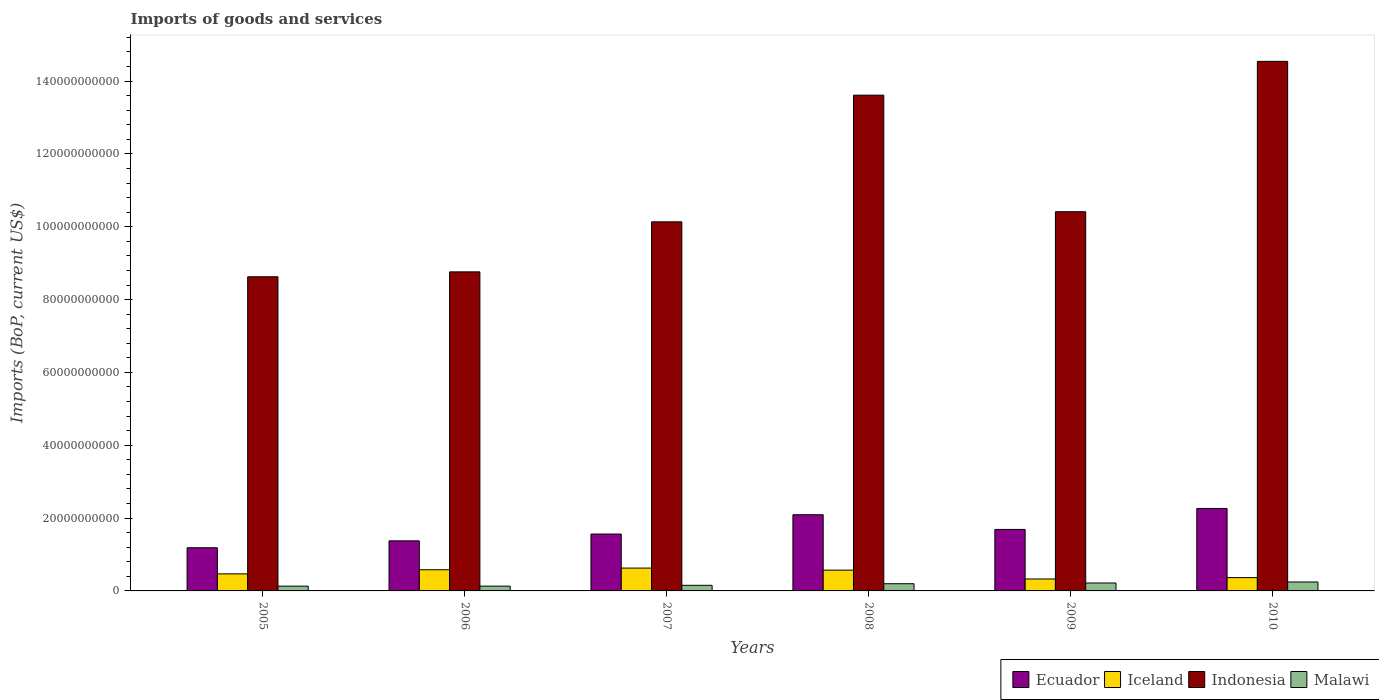Are the number of bars per tick equal to the number of legend labels?
Make the answer very short. Yes. How many bars are there on the 2nd tick from the right?
Make the answer very short. 4. What is the amount spent on imports in Iceland in 2005?
Keep it short and to the point. 4.68e+09. Across all years, what is the maximum amount spent on imports in Iceland?
Keep it short and to the point. 6.27e+09. Across all years, what is the minimum amount spent on imports in Iceland?
Provide a short and direct response. 3.28e+09. In which year was the amount spent on imports in Ecuador minimum?
Keep it short and to the point. 2005. What is the total amount spent on imports in Iceland in the graph?
Keep it short and to the point. 2.94e+1. What is the difference between the amount spent on imports in Iceland in 2008 and that in 2009?
Ensure brevity in your answer.  2.43e+09. What is the difference between the amount spent on imports in Ecuador in 2005 and the amount spent on imports in Iceland in 2006?
Give a very brief answer. 6.04e+09. What is the average amount spent on imports in Iceland per year?
Your answer should be very brief. 4.90e+09. In the year 2006, what is the difference between the amount spent on imports in Iceland and amount spent on imports in Ecuador?
Ensure brevity in your answer.  -7.93e+09. What is the ratio of the amount spent on imports in Iceland in 2005 to that in 2009?
Give a very brief answer. 1.43. Is the amount spent on imports in Iceland in 2005 less than that in 2010?
Your answer should be very brief. No. What is the difference between the highest and the second highest amount spent on imports in Malawi?
Offer a terse response. 2.83e+08. What is the difference between the highest and the lowest amount spent on imports in Malawi?
Your answer should be very brief. 1.15e+09. In how many years, is the amount spent on imports in Malawi greater than the average amount spent on imports in Malawi taken over all years?
Offer a very short reply. 3. Is the sum of the amount spent on imports in Iceland in 2009 and 2010 greater than the maximum amount spent on imports in Ecuador across all years?
Offer a terse response. No. Is it the case that in every year, the sum of the amount spent on imports in Ecuador and amount spent on imports in Iceland is greater than the sum of amount spent on imports in Indonesia and amount spent on imports in Malawi?
Your answer should be very brief. No. What does the 1st bar from the left in 2006 represents?
Make the answer very short. Ecuador. Where does the legend appear in the graph?
Offer a terse response. Bottom right. What is the title of the graph?
Give a very brief answer. Imports of goods and services. Does "Middle East & North Africa (all income levels)" appear as one of the legend labels in the graph?
Keep it short and to the point. No. What is the label or title of the X-axis?
Offer a terse response. Years. What is the label or title of the Y-axis?
Ensure brevity in your answer.  Imports (BoP, current US$). What is the Imports (BoP, current US$) in Ecuador in 2005?
Your answer should be very brief. 1.19e+1. What is the Imports (BoP, current US$) in Iceland in 2005?
Offer a very short reply. 4.68e+09. What is the Imports (BoP, current US$) of Indonesia in 2005?
Provide a short and direct response. 8.63e+1. What is the Imports (BoP, current US$) in Malawi in 2005?
Offer a very short reply. 1.31e+09. What is the Imports (BoP, current US$) in Ecuador in 2006?
Give a very brief answer. 1.37e+1. What is the Imports (BoP, current US$) in Iceland in 2006?
Give a very brief answer. 5.82e+09. What is the Imports (BoP, current US$) of Indonesia in 2006?
Your answer should be compact. 8.76e+1. What is the Imports (BoP, current US$) of Malawi in 2006?
Provide a succinct answer. 1.32e+09. What is the Imports (BoP, current US$) in Ecuador in 2007?
Your answer should be compact. 1.56e+1. What is the Imports (BoP, current US$) in Iceland in 2007?
Provide a short and direct response. 6.27e+09. What is the Imports (BoP, current US$) of Indonesia in 2007?
Ensure brevity in your answer.  1.01e+11. What is the Imports (BoP, current US$) in Malawi in 2007?
Your response must be concise. 1.54e+09. What is the Imports (BoP, current US$) in Ecuador in 2008?
Give a very brief answer. 2.09e+1. What is the Imports (BoP, current US$) of Iceland in 2008?
Keep it short and to the point. 5.71e+09. What is the Imports (BoP, current US$) in Indonesia in 2008?
Your answer should be compact. 1.36e+11. What is the Imports (BoP, current US$) in Malawi in 2008?
Offer a very short reply. 1.98e+09. What is the Imports (BoP, current US$) in Ecuador in 2009?
Provide a succinct answer. 1.69e+1. What is the Imports (BoP, current US$) in Iceland in 2009?
Offer a very short reply. 3.28e+09. What is the Imports (BoP, current US$) of Indonesia in 2009?
Your response must be concise. 1.04e+11. What is the Imports (BoP, current US$) of Malawi in 2009?
Offer a terse response. 2.18e+09. What is the Imports (BoP, current US$) in Ecuador in 2010?
Provide a short and direct response. 2.26e+1. What is the Imports (BoP, current US$) of Iceland in 2010?
Offer a very short reply. 3.65e+09. What is the Imports (BoP, current US$) of Indonesia in 2010?
Provide a succinct answer. 1.45e+11. What is the Imports (BoP, current US$) of Malawi in 2010?
Keep it short and to the point. 2.46e+09. Across all years, what is the maximum Imports (BoP, current US$) of Ecuador?
Your response must be concise. 2.26e+1. Across all years, what is the maximum Imports (BoP, current US$) in Iceland?
Ensure brevity in your answer.  6.27e+09. Across all years, what is the maximum Imports (BoP, current US$) of Indonesia?
Your answer should be very brief. 1.45e+11. Across all years, what is the maximum Imports (BoP, current US$) in Malawi?
Offer a terse response. 2.46e+09. Across all years, what is the minimum Imports (BoP, current US$) of Ecuador?
Give a very brief answer. 1.19e+1. Across all years, what is the minimum Imports (BoP, current US$) of Iceland?
Provide a succinct answer. 3.28e+09. Across all years, what is the minimum Imports (BoP, current US$) in Indonesia?
Offer a terse response. 8.63e+1. Across all years, what is the minimum Imports (BoP, current US$) in Malawi?
Make the answer very short. 1.31e+09. What is the total Imports (BoP, current US$) in Ecuador in the graph?
Your answer should be compact. 1.02e+11. What is the total Imports (BoP, current US$) in Iceland in the graph?
Give a very brief answer. 2.94e+1. What is the total Imports (BoP, current US$) of Indonesia in the graph?
Keep it short and to the point. 6.61e+11. What is the total Imports (BoP, current US$) in Malawi in the graph?
Offer a terse response. 1.08e+1. What is the difference between the Imports (BoP, current US$) of Ecuador in 2005 and that in 2006?
Make the answer very short. -1.90e+09. What is the difference between the Imports (BoP, current US$) of Iceland in 2005 and that in 2006?
Offer a terse response. -1.13e+09. What is the difference between the Imports (BoP, current US$) in Indonesia in 2005 and that in 2006?
Your answer should be compact. -1.35e+09. What is the difference between the Imports (BoP, current US$) in Malawi in 2005 and that in 2006?
Your answer should be compact. -1.06e+07. What is the difference between the Imports (BoP, current US$) in Ecuador in 2005 and that in 2007?
Your response must be concise. -3.77e+09. What is the difference between the Imports (BoP, current US$) in Iceland in 2005 and that in 2007?
Provide a succinct answer. -1.59e+09. What is the difference between the Imports (BoP, current US$) in Indonesia in 2005 and that in 2007?
Your answer should be very brief. -1.51e+1. What is the difference between the Imports (BoP, current US$) in Malawi in 2005 and that in 2007?
Keep it short and to the point. -2.29e+08. What is the difference between the Imports (BoP, current US$) in Ecuador in 2005 and that in 2008?
Give a very brief answer. -9.07e+09. What is the difference between the Imports (BoP, current US$) of Iceland in 2005 and that in 2008?
Your response must be concise. -1.03e+09. What is the difference between the Imports (BoP, current US$) in Indonesia in 2005 and that in 2008?
Offer a terse response. -4.99e+1. What is the difference between the Imports (BoP, current US$) of Malawi in 2005 and that in 2008?
Give a very brief answer. -6.68e+08. What is the difference between the Imports (BoP, current US$) in Ecuador in 2005 and that in 2009?
Make the answer very short. -5.04e+09. What is the difference between the Imports (BoP, current US$) of Iceland in 2005 and that in 2009?
Offer a terse response. 1.40e+09. What is the difference between the Imports (BoP, current US$) of Indonesia in 2005 and that in 2009?
Provide a short and direct response. -1.79e+1. What is the difference between the Imports (BoP, current US$) in Malawi in 2005 and that in 2009?
Your answer should be very brief. -8.66e+08. What is the difference between the Imports (BoP, current US$) of Ecuador in 2005 and that in 2010?
Your answer should be compact. -1.08e+1. What is the difference between the Imports (BoP, current US$) of Iceland in 2005 and that in 2010?
Give a very brief answer. 1.03e+09. What is the difference between the Imports (BoP, current US$) of Indonesia in 2005 and that in 2010?
Your answer should be compact. -5.92e+1. What is the difference between the Imports (BoP, current US$) of Malawi in 2005 and that in 2010?
Make the answer very short. -1.15e+09. What is the difference between the Imports (BoP, current US$) of Ecuador in 2006 and that in 2007?
Ensure brevity in your answer.  -1.87e+09. What is the difference between the Imports (BoP, current US$) in Iceland in 2006 and that in 2007?
Your answer should be very brief. -4.53e+08. What is the difference between the Imports (BoP, current US$) in Indonesia in 2006 and that in 2007?
Provide a succinct answer. -1.37e+1. What is the difference between the Imports (BoP, current US$) in Malawi in 2006 and that in 2007?
Make the answer very short. -2.18e+08. What is the difference between the Imports (BoP, current US$) in Ecuador in 2006 and that in 2008?
Your response must be concise. -7.18e+09. What is the difference between the Imports (BoP, current US$) of Iceland in 2006 and that in 2008?
Ensure brevity in your answer.  1.07e+08. What is the difference between the Imports (BoP, current US$) in Indonesia in 2006 and that in 2008?
Give a very brief answer. -4.85e+1. What is the difference between the Imports (BoP, current US$) of Malawi in 2006 and that in 2008?
Offer a terse response. -6.58e+08. What is the difference between the Imports (BoP, current US$) of Ecuador in 2006 and that in 2009?
Provide a succinct answer. -3.14e+09. What is the difference between the Imports (BoP, current US$) of Iceland in 2006 and that in 2009?
Give a very brief answer. 2.54e+09. What is the difference between the Imports (BoP, current US$) of Indonesia in 2006 and that in 2009?
Give a very brief answer. -1.65e+1. What is the difference between the Imports (BoP, current US$) of Malawi in 2006 and that in 2009?
Give a very brief answer. -8.56e+08. What is the difference between the Imports (BoP, current US$) of Ecuador in 2006 and that in 2010?
Provide a short and direct response. -8.89e+09. What is the difference between the Imports (BoP, current US$) in Iceland in 2006 and that in 2010?
Your answer should be very brief. 2.16e+09. What is the difference between the Imports (BoP, current US$) in Indonesia in 2006 and that in 2010?
Make the answer very short. -5.78e+1. What is the difference between the Imports (BoP, current US$) in Malawi in 2006 and that in 2010?
Provide a succinct answer. -1.14e+09. What is the difference between the Imports (BoP, current US$) in Ecuador in 2007 and that in 2008?
Your response must be concise. -5.31e+09. What is the difference between the Imports (BoP, current US$) of Iceland in 2007 and that in 2008?
Offer a terse response. 5.60e+08. What is the difference between the Imports (BoP, current US$) of Indonesia in 2007 and that in 2008?
Your response must be concise. -3.48e+1. What is the difference between the Imports (BoP, current US$) of Malawi in 2007 and that in 2008?
Your answer should be very brief. -4.40e+08. What is the difference between the Imports (BoP, current US$) in Ecuador in 2007 and that in 2009?
Make the answer very short. -1.27e+09. What is the difference between the Imports (BoP, current US$) of Iceland in 2007 and that in 2009?
Provide a succinct answer. 2.99e+09. What is the difference between the Imports (BoP, current US$) of Indonesia in 2007 and that in 2009?
Offer a very short reply. -2.78e+09. What is the difference between the Imports (BoP, current US$) of Malawi in 2007 and that in 2009?
Ensure brevity in your answer.  -6.38e+08. What is the difference between the Imports (BoP, current US$) in Ecuador in 2007 and that in 2010?
Offer a terse response. -7.02e+09. What is the difference between the Imports (BoP, current US$) in Iceland in 2007 and that in 2010?
Give a very brief answer. 2.61e+09. What is the difference between the Imports (BoP, current US$) in Indonesia in 2007 and that in 2010?
Provide a short and direct response. -4.41e+1. What is the difference between the Imports (BoP, current US$) in Malawi in 2007 and that in 2010?
Your answer should be compact. -9.20e+08. What is the difference between the Imports (BoP, current US$) of Ecuador in 2008 and that in 2009?
Offer a terse response. 4.04e+09. What is the difference between the Imports (BoP, current US$) of Iceland in 2008 and that in 2009?
Keep it short and to the point. 2.43e+09. What is the difference between the Imports (BoP, current US$) of Indonesia in 2008 and that in 2009?
Provide a succinct answer. 3.20e+1. What is the difference between the Imports (BoP, current US$) of Malawi in 2008 and that in 2009?
Provide a short and direct response. -1.98e+08. What is the difference between the Imports (BoP, current US$) of Ecuador in 2008 and that in 2010?
Your response must be concise. -1.71e+09. What is the difference between the Imports (BoP, current US$) of Iceland in 2008 and that in 2010?
Provide a short and direct response. 2.05e+09. What is the difference between the Imports (BoP, current US$) of Indonesia in 2008 and that in 2010?
Offer a terse response. -9.29e+09. What is the difference between the Imports (BoP, current US$) in Malawi in 2008 and that in 2010?
Make the answer very short. -4.80e+08. What is the difference between the Imports (BoP, current US$) in Ecuador in 2009 and that in 2010?
Provide a succinct answer. -5.75e+09. What is the difference between the Imports (BoP, current US$) of Iceland in 2009 and that in 2010?
Ensure brevity in your answer.  -3.75e+08. What is the difference between the Imports (BoP, current US$) of Indonesia in 2009 and that in 2010?
Provide a short and direct response. -4.13e+1. What is the difference between the Imports (BoP, current US$) of Malawi in 2009 and that in 2010?
Give a very brief answer. -2.83e+08. What is the difference between the Imports (BoP, current US$) in Ecuador in 2005 and the Imports (BoP, current US$) in Iceland in 2006?
Your response must be concise. 6.04e+09. What is the difference between the Imports (BoP, current US$) in Ecuador in 2005 and the Imports (BoP, current US$) in Indonesia in 2006?
Offer a very short reply. -7.58e+1. What is the difference between the Imports (BoP, current US$) in Ecuador in 2005 and the Imports (BoP, current US$) in Malawi in 2006?
Your response must be concise. 1.05e+1. What is the difference between the Imports (BoP, current US$) in Iceland in 2005 and the Imports (BoP, current US$) in Indonesia in 2006?
Offer a terse response. -8.29e+1. What is the difference between the Imports (BoP, current US$) of Iceland in 2005 and the Imports (BoP, current US$) of Malawi in 2006?
Make the answer very short. 3.36e+09. What is the difference between the Imports (BoP, current US$) in Indonesia in 2005 and the Imports (BoP, current US$) in Malawi in 2006?
Provide a short and direct response. 8.49e+1. What is the difference between the Imports (BoP, current US$) in Ecuador in 2005 and the Imports (BoP, current US$) in Iceland in 2007?
Make the answer very short. 5.58e+09. What is the difference between the Imports (BoP, current US$) of Ecuador in 2005 and the Imports (BoP, current US$) of Indonesia in 2007?
Your answer should be compact. -8.95e+1. What is the difference between the Imports (BoP, current US$) of Ecuador in 2005 and the Imports (BoP, current US$) of Malawi in 2007?
Offer a very short reply. 1.03e+1. What is the difference between the Imports (BoP, current US$) in Iceland in 2005 and the Imports (BoP, current US$) in Indonesia in 2007?
Offer a terse response. -9.67e+1. What is the difference between the Imports (BoP, current US$) in Iceland in 2005 and the Imports (BoP, current US$) in Malawi in 2007?
Make the answer very short. 3.14e+09. What is the difference between the Imports (BoP, current US$) of Indonesia in 2005 and the Imports (BoP, current US$) of Malawi in 2007?
Offer a terse response. 8.47e+1. What is the difference between the Imports (BoP, current US$) in Ecuador in 2005 and the Imports (BoP, current US$) in Iceland in 2008?
Offer a very short reply. 6.14e+09. What is the difference between the Imports (BoP, current US$) in Ecuador in 2005 and the Imports (BoP, current US$) in Indonesia in 2008?
Make the answer very short. -1.24e+11. What is the difference between the Imports (BoP, current US$) in Ecuador in 2005 and the Imports (BoP, current US$) in Malawi in 2008?
Ensure brevity in your answer.  9.87e+09. What is the difference between the Imports (BoP, current US$) of Iceland in 2005 and the Imports (BoP, current US$) of Indonesia in 2008?
Your answer should be compact. -1.31e+11. What is the difference between the Imports (BoP, current US$) in Iceland in 2005 and the Imports (BoP, current US$) in Malawi in 2008?
Offer a very short reply. 2.70e+09. What is the difference between the Imports (BoP, current US$) of Indonesia in 2005 and the Imports (BoP, current US$) of Malawi in 2008?
Provide a short and direct response. 8.43e+1. What is the difference between the Imports (BoP, current US$) in Ecuador in 2005 and the Imports (BoP, current US$) in Iceland in 2009?
Your answer should be very brief. 8.57e+09. What is the difference between the Imports (BoP, current US$) in Ecuador in 2005 and the Imports (BoP, current US$) in Indonesia in 2009?
Your answer should be compact. -9.23e+1. What is the difference between the Imports (BoP, current US$) of Ecuador in 2005 and the Imports (BoP, current US$) of Malawi in 2009?
Ensure brevity in your answer.  9.68e+09. What is the difference between the Imports (BoP, current US$) in Iceland in 2005 and the Imports (BoP, current US$) in Indonesia in 2009?
Give a very brief answer. -9.94e+1. What is the difference between the Imports (BoP, current US$) of Iceland in 2005 and the Imports (BoP, current US$) of Malawi in 2009?
Offer a very short reply. 2.51e+09. What is the difference between the Imports (BoP, current US$) in Indonesia in 2005 and the Imports (BoP, current US$) in Malawi in 2009?
Provide a succinct answer. 8.41e+1. What is the difference between the Imports (BoP, current US$) of Ecuador in 2005 and the Imports (BoP, current US$) of Iceland in 2010?
Your response must be concise. 8.20e+09. What is the difference between the Imports (BoP, current US$) of Ecuador in 2005 and the Imports (BoP, current US$) of Indonesia in 2010?
Ensure brevity in your answer.  -1.34e+11. What is the difference between the Imports (BoP, current US$) of Ecuador in 2005 and the Imports (BoP, current US$) of Malawi in 2010?
Your response must be concise. 9.39e+09. What is the difference between the Imports (BoP, current US$) of Iceland in 2005 and the Imports (BoP, current US$) of Indonesia in 2010?
Your answer should be compact. -1.41e+11. What is the difference between the Imports (BoP, current US$) in Iceland in 2005 and the Imports (BoP, current US$) in Malawi in 2010?
Offer a terse response. 2.22e+09. What is the difference between the Imports (BoP, current US$) in Indonesia in 2005 and the Imports (BoP, current US$) in Malawi in 2010?
Offer a terse response. 8.38e+1. What is the difference between the Imports (BoP, current US$) in Ecuador in 2006 and the Imports (BoP, current US$) in Iceland in 2007?
Make the answer very short. 7.48e+09. What is the difference between the Imports (BoP, current US$) of Ecuador in 2006 and the Imports (BoP, current US$) of Indonesia in 2007?
Provide a short and direct response. -8.76e+1. What is the difference between the Imports (BoP, current US$) in Ecuador in 2006 and the Imports (BoP, current US$) in Malawi in 2007?
Keep it short and to the point. 1.22e+1. What is the difference between the Imports (BoP, current US$) in Iceland in 2006 and the Imports (BoP, current US$) in Indonesia in 2007?
Your answer should be very brief. -9.55e+1. What is the difference between the Imports (BoP, current US$) of Iceland in 2006 and the Imports (BoP, current US$) of Malawi in 2007?
Offer a terse response. 4.28e+09. What is the difference between the Imports (BoP, current US$) in Indonesia in 2006 and the Imports (BoP, current US$) in Malawi in 2007?
Your answer should be compact. 8.61e+1. What is the difference between the Imports (BoP, current US$) of Ecuador in 2006 and the Imports (BoP, current US$) of Iceland in 2008?
Ensure brevity in your answer.  8.04e+09. What is the difference between the Imports (BoP, current US$) of Ecuador in 2006 and the Imports (BoP, current US$) of Indonesia in 2008?
Make the answer very short. -1.22e+11. What is the difference between the Imports (BoP, current US$) in Ecuador in 2006 and the Imports (BoP, current US$) in Malawi in 2008?
Your response must be concise. 1.18e+1. What is the difference between the Imports (BoP, current US$) in Iceland in 2006 and the Imports (BoP, current US$) in Indonesia in 2008?
Make the answer very short. -1.30e+11. What is the difference between the Imports (BoP, current US$) of Iceland in 2006 and the Imports (BoP, current US$) of Malawi in 2008?
Your answer should be compact. 3.84e+09. What is the difference between the Imports (BoP, current US$) in Indonesia in 2006 and the Imports (BoP, current US$) in Malawi in 2008?
Your response must be concise. 8.56e+1. What is the difference between the Imports (BoP, current US$) in Ecuador in 2006 and the Imports (BoP, current US$) in Iceland in 2009?
Make the answer very short. 1.05e+1. What is the difference between the Imports (BoP, current US$) in Ecuador in 2006 and the Imports (BoP, current US$) in Indonesia in 2009?
Ensure brevity in your answer.  -9.04e+1. What is the difference between the Imports (BoP, current US$) in Ecuador in 2006 and the Imports (BoP, current US$) in Malawi in 2009?
Keep it short and to the point. 1.16e+1. What is the difference between the Imports (BoP, current US$) in Iceland in 2006 and the Imports (BoP, current US$) in Indonesia in 2009?
Offer a terse response. -9.83e+1. What is the difference between the Imports (BoP, current US$) in Iceland in 2006 and the Imports (BoP, current US$) in Malawi in 2009?
Provide a succinct answer. 3.64e+09. What is the difference between the Imports (BoP, current US$) in Indonesia in 2006 and the Imports (BoP, current US$) in Malawi in 2009?
Make the answer very short. 8.54e+1. What is the difference between the Imports (BoP, current US$) of Ecuador in 2006 and the Imports (BoP, current US$) of Iceland in 2010?
Offer a very short reply. 1.01e+1. What is the difference between the Imports (BoP, current US$) in Ecuador in 2006 and the Imports (BoP, current US$) in Indonesia in 2010?
Your response must be concise. -1.32e+11. What is the difference between the Imports (BoP, current US$) in Ecuador in 2006 and the Imports (BoP, current US$) in Malawi in 2010?
Offer a terse response. 1.13e+1. What is the difference between the Imports (BoP, current US$) in Iceland in 2006 and the Imports (BoP, current US$) in Indonesia in 2010?
Provide a short and direct response. -1.40e+11. What is the difference between the Imports (BoP, current US$) in Iceland in 2006 and the Imports (BoP, current US$) in Malawi in 2010?
Your answer should be compact. 3.36e+09. What is the difference between the Imports (BoP, current US$) in Indonesia in 2006 and the Imports (BoP, current US$) in Malawi in 2010?
Give a very brief answer. 8.52e+1. What is the difference between the Imports (BoP, current US$) of Ecuador in 2007 and the Imports (BoP, current US$) of Iceland in 2008?
Provide a short and direct response. 9.91e+09. What is the difference between the Imports (BoP, current US$) of Ecuador in 2007 and the Imports (BoP, current US$) of Indonesia in 2008?
Provide a succinct answer. -1.21e+11. What is the difference between the Imports (BoP, current US$) of Ecuador in 2007 and the Imports (BoP, current US$) of Malawi in 2008?
Ensure brevity in your answer.  1.36e+1. What is the difference between the Imports (BoP, current US$) of Iceland in 2007 and the Imports (BoP, current US$) of Indonesia in 2008?
Give a very brief answer. -1.30e+11. What is the difference between the Imports (BoP, current US$) of Iceland in 2007 and the Imports (BoP, current US$) of Malawi in 2008?
Offer a very short reply. 4.29e+09. What is the difference between the Imports (BoP, current US$) of Indonesia in 2007 and the Imports (BoP, current US$) of Malawi in 2008?
Give a very brief answer. 9.94e+1. What is the difference between the Imports (BoP, current US$) in Ecuador in 2007 and the Imports (BoP, current US$) in Iceland in 2009?
Offer a very short reply. 1.23e+1. What is the difference between the Imports (BoP, current US$) of Ecuador in 2007 and the Imports (BoP, current US$) of Indonesia in 2009?
Offer a very short reply. -8.85e+1. What is the difference between the Imports (BoP, current US$) in Ecuador in 2007 and the Imports (BoP, current US$) in Malawi in 2009?
Make the answer very short. 1.34e+1. What is the difference between the Imports (BoP, current US$) of Iceland in 2007 and the Imports (BoP, current US$) of Indonesia in 2009?
Provide a short and direct response. -9.79e+1. What is the difference between the Imports (BoP, current US$) of Iceland in 2007 and the Imports (BoP, current US$) of Malawi in 2009?
Keep it short and to the point. 4.09e+09. What is the difference between the Imports (BoP, current US$) in Indonesia in 2007 and the Imports (BoP, current US$) in Malawi in 2009?
Keep it short and to the point. 9.92e+1. What is the difference between the Imports (BoP, current US$) in Ecuador in 2007 and the Imports (BoP, current US$) in Iceland in 2010?
Your answer should be very brief. 1.20e+1. What is the difference between the Imports (BoP, current US$) of Ecuador in 2007 and the Imports (BoP, current US$) of Indonesia in 2010?
Your answer should be compact. -1.30e+11. What is the difference between the Imports (BoP, current US$) in Ecuador in 2007 and the Imports (BoP, current US$) in Malawi in 2010?
Your answer should be very brief. 1.32e+1. What is the difference between the Imports (BoP, current US$) of Iceland in 2007 and the Imports (BoP, current US$) of Indonesia in 2010?
Make the answer very short. -1.39e+11. What is the difference between the Imports (BoP, current US$) in Iceland in 2007 and the Imports (BoP, current US$) in Malawi in 2010?
Make the answer very short. 3.81e+09. What is the difference between the Imports (BoP, current US$) in Indonesia in 2007 and the Imports (BoP, current US$) in Malawi in 2010?
Give a very brief answer. 9.89e+1. What is the difference between the Imports (BoP, current US$) in Ecuador in 2008 and the Imports (BoP, current US$) in Iceland in 2009?
Provide a succinct answer. 1.76e+1. What is the difference between the Imports (BoP, current US$) in Ecuador in 2008 and the Imports (BoP, current US$) in Indonesia in 2009?
Your answer should be compact. -8.32e+1. What is the difference between the Imports (BoP, current US$) of Ecuador in 2008 and the Imports (BoP, current US$) of Malawi in 2009?
Provide a short and direct response. 1.87e+1. What is the difference between the Imports (BoP, current US$) in Iceland in 2008 and the Imports (BoP, current US$) in Indonesia in 2009?
Keep it short and to the point. -9.84e+1. What is the difference between the Imports (BoP, current US$) in Iceland in 2008 and the Imports (BoP, current US$) in Malawi in 2009?
Provide a succinct answer. 3.53e+09. What is the difference between the Imports (BoP, current US$) of Indonesia in 2008 and the Imports (BoP, current US$) of Malawi in 2009?
Provide a short and direct response. 1.34e+11. What is the difference between the Imports (BoP, current US$) of Ecuador in 2008 and the Imports (BoP, current US$) of Iceland in 2010?
Provide a succinct answer. 1.73e+1. What is the difference between the Imports (BoP, current US$) in Ecuador in 2008 and the Imports (BoP, current US$) in Indonesia in 2010?
Provide a short and direct response. -1.24e+11. What is the difference between the Imports (BoP, current US$) in Ecuador in 2008 and the Imports (BoP, current US$) in Malawi in 2010?
Provide a short and direct response. 1.85e+1. What is the difference between the Imports (BoP, current US$) of Iceland in 2008 and the Imports (BoP, current US$) of Indonesia in 2010?
Make the answer very short. -1.40e+11. What is the difference between the Imports (BoP, current US$) in Iceland in 2008 and the Imports (BoP, current US$) in Malawi in 2010?
Give a very brief answer. 3.25e+09. What is the difference between the Imports (BoP, current US$) of Indonesia in 2008 and the Imports (BoP, current US$) of Malawi in 2010?
Ensure brevity in your answer.  1.34e+11. What is the difference between the Imports (BoP, current US$) in Ecuador in 2009 and the Imports (BoP, current US$) in Iceland in 2010?
Provide a short and direct response. 1.32e+1. What is the difference between the Imports (BoP, current US$) of Ecuador in 2009 and the Imports (BoP, current US$) of Indonesia in 2010?
Your answer should be very brief. -1.29e+11. What is the difference between the Imports (BoP, current US$) of Ecuador in 2009 and the Imports (BoP, current US$) of Malawi in 2010?
Provide a succinct answer. 1.44e+1. What is the difference between the Imports (BoP, current US$) in Iceland in 2009 and the Imports (BoP, current US$) in Indonesia in 2010?
Provide a succinct answer. -1.42e+11. What is the difference between the Imports (BoP, current US$) of Iceland in 2009 and the Imports (BoP, current US$) of Malawi in 2010?
Provide a short and direct response. 8.22e+08. What is the difference between the Imports (BoP, current US$) of Indonesia in 2009 and the Imports (BoP, current US$) of Malawi in 2010?
Make the answer very short. 1.02e+11. What is the average Imports (BoP, current US$) in Ecuador per year?
Provide a short and direct response. 1.69e+1. What is the average Imports (BoP, current US$) in Iceland per year?
Your response must be concise. 4.90e+09. What is the average Imports (BoP, current US$) of Indonesia per year?
Make the answer very short. 1.10e+11. What is the average Imports (BoP, current US$) of Malawi per year?
Offer a terse response. 1.80e+09. In the year 2005, what is the difference between the Imports (BoP, current US$) of Ecuador and Imports (BoP, current US$) of Iceland?
Ensure brevity in your answer.  7.17e+09. In the year 2005, what is the difference between the Imports (BoP, current US$) of Ecuador and Imports (BoP, current US$) of Indonesia?
Your response must be concise. -7.44e+1. In the year 2005, what is the difference between the Imports (BoP, current US$) in Ecuador and Imports (BoP, current US$) in Malawi?
Provide a short and direct response. 1.05e+1. In the year 2005, what is the difference between the Imports (BoP, current US$) in Iceland and Imports (BoP, current US$) in Indonesia?
Provide a succinct answer. -8.16e+1. In the year 2005, what is the difference between the Imports (BoP, current US$) in Iceland and Imports (BoP, current US$) in Malawi?
Provide a succinct answer. 3.37e+09. In the year 2005, what is the difference between the Imports (BoP, current US$) of Indonesia and Imports (BoP, current US$) of Malawi?
Make the answer very short. 8.50e+1. In the year 2006, what is the difference between the Imports (BoP, current US$) in Ecuador and Imports (BoP, current US$) in Iceland?
Provide a short and direct response. 7.93e+09. In the year 2006, what is the difference between the Imports (BoP, current US$) in Ecuador and Imports (BoP, current US$) in Indonesia?
Your response must be concise. -7.39e+1. In the year 2006, what is the difference between the Imports (BoP, current US$) of Ecuador and Imports (BoP, current US$) of Malawi?
Make the answer very short. 1.24e+1. In the year 2006, what is the difference between the Imports (BoP, current US$) of Iceland and Imports (BoP, current US$) of Indonesia?
Make the answer very short. -8.18e+1. In the year 2006, what is the difference between the Imports (BoP, current US$) in Iceland and Imports (BoP, current US$) in Malawi?
Your response must be concise. 4.50e+09. In the year 2006, what is the difference between the Imports (BoP, current US$) in Indonesia and Imports (BoP, current US$) in Malawi?
Keep it short and to the point. 8.63e+1. In the year 2007, what is the difference between the Imports (BoP, current US$) of Ecuador and Imports (BoP, current US$) of Iceland?
Ensure brevity in your answer.  9.35e+09. In the year 2007, what is the difference between the Imports (BoP, current US$) in Ecuador and Imports (BoP, current US$) in Indonesia?
Your answer should be compact. -8.57e+1. In the year 2007, what is the difference between the Imports (BoP, current US$) in Ecuador and Imports (BoP, current US$) in Malawi?
Make the answer very short. 1.41e+1. In the year 2007, what is the difference between the Imports (BoP, current US$) in Iceland and Imports (BoP, current US$) in Indonesia?
Offer a terse response. -9.51e+1. In the year 2007, what is the difference between the Imports (BoP, current US$) in Iceland and Imports (BoP, current US$) in Malawi?
Your answer should be compact. 4.73e+09. In the year 2007, what is the difference between the Imports (BoP, current US$) of Indonesia and Imports (BoP, current US$) of Malawi?
Give a very brief answer. 9.98e+1. In the year 2008, what is the difference between the Imports (BoP, current US$) of Ecuador and Imports (BoP, current US$) of Iceland?
Offer a very short reply. 1.52e+1. In the year 2008, what is the difference between the Imports (BoP, current US$) in Ecuador and Imports (BoP, current US$) in Indonesia?
Provide a short and direct response. -1.15e+11. In the year 2008, what is the difference between the Imports (BoP, current US$) in Ecuador and Imports (BoP, current US$) in Malawi?
Offer a terse response. 1.89e+1. In the year 2008, what is the difference between the Imports (BoP, current US$) of Iceland and Imports (BoP, current US$) of Indonesia?
Your answer should be compact. -1.30e+11. In the year 2008, what is the difference between the Imports (BoP, current US$) of Iceland and Imports (BoP, current US$) of Malawi?
Keep it short and to the point. 3.73e+09. In the year 2008, what is the difference between the Imports (BoP, current US$) in Indonesia and Imports (BoP, current US$) in Malawi?
Make the answer very short. 1.34e+11. In the year 2009, what is the difference between the Imports (BoP, current US$) in Ecuador and Imports (BoP, current US$) in Iceland?
Give a very brief answer. 1.36e+1. In the year 2009, what is the difference between the Imports (BoP, current US$) of Ecuador and Imports (BoP, current US$) of Indonesia?
Give a very brief answer. -8.72e+1. In the year 2009, what is the difference between the Imports (BoP, current US$) of Ecuador and Imports (BoP, current US$) of Malawi?
Keep it short and to the point. 1.47e+1. In the year 2009, what is the difference between the Imports (BoP, current US$) of Iceland and Imports (BoP, current US$) of Indonesia?
Make the answer very short. -1.01e+11. In the year 2009, what is the difference between the Imports (BoP, current US$) of Iceland and Imports (BoP, current US$) of Malawi?
Your answer should be very brief. 1.10e+09. In the year 2009, what is the difference between the Imports (BoP, current US$) in Indonesia and Imports (BoP, current US$) in Malawi?
Provide a succinct answer. 1.02e+11. In the year 2010, what is the difference between the Imports (BoP, current US$) of Ecuador and Imports (BoP, current US$) of Iceland?
Offer a terse response. 1.90e+1. In the year 2010, what is the difference between the Imports (BoP, current US$) of Ecuador and Imports (BoP, current US$) of Indonesia?
Provide a short and direct response. -1.23e+11. In the year 2010, what is the difference between the Imports (BoP, current US$) of Ecuador and Imports (BoP, current US$) of Malawi?
Your answer should be compact. 2.02e+1. In the year 2010, what is the difference between the Imports (BoP, current US$) in Iceland and Imports (BoP, current US$) in Indonesia?
Give a very brief answer. -1.42e+11. In the year 2010, what is the difference between the Imports (BoP, current US$) in Iceland and Imports (BoP, current US$) in Malawi?
Your response must be concise. 1.20e+09. In the year 2010, what is the difference between the Imports (BoP, current US$) of Indonesia and Imports (BoP, current US$) of Malawi?
Your answer should be very brief. 1.43e+11. What is the ratio of the Imports (BoP, current US$) of Ecuador in 2005 to that in 2006?
Give a very brief answer. 0.86. What is the ratio of the Imports (BoP, current US$) in Iceland in 2005 to that in 2006?
Ensure brevity in your answer.  0.8. What is the ratio of the Imports (BoP, current US$) of Indonesia in 2005 to that in 2006?
Provide a short and direct response. 0.98. What is the ratio of the Imports (BoP, current US$) in Malawi in 2005 to that in 2006?
Offer a terse response. 0.99. What is the ratio of the Imports (BoP, current US$) of Ecuador in 2005 to that in 2007?
Keep it short and to the point. 0.76. What is the ratio of the Imports (BoP, current US$) of Iceland in 2005 to that in 2007?
Provide a short and direct response. 0.75. What is the ratio of the Imports (BoP, current US$) of Indonesia in 2005 to that in 2007?
Make the answer very short. 0.85. What is the ratio of the Imports (BoP, current US$) of Malawi in 2005 to that in 2007?
Ensure brevity in your answer.  0.85. What is the ratio of the Imports (BoP, current US$) of Ecuador in 2005 to that in 2008?
Offer a very short reply. 0.57. What is the ratio of the Imports (BoP, current US$) in Iceland in 2005 to that in 2008?
Your answer should be compact. 0.82. What is the ratio of the Imports (BoP, current US$) in Indonesia in 2005 to that in 2008?
Provide a short and direct response. 0.63. What is the ratio of the Imports (BoP, current US$) of Malawi in 2005 to that in 2008?
Provide a short and direct response. 0.66. What is the ratio of the Imports (BoP, current US$) of Ecuador in 2005 to that in 2009?
Your response must be concise. 0.7. What is the ratio of the Imports (BoP, current US$) of Iceland in 2005 to that in 2009?
Your answer should be very brief. 1.43. What is the ratio of the Imports (BoP, current US$) of Indonesia in 2005 to that in 2009?
Ensure brevity in your answer.  0.83. What is the ratio of the Imports (BoP, current US$) in Malawi in 2005 to that in 2009?
Provide a short and direct response. 0.6. What is the ratio of the Imports (BoP, current US$) in Ecuador in 2005 to that in 2010?
Provide a succinct answer. 0.52. What is the ratio of the Imports (BoP, current US$) in Iceland in 2005 to that in 2010?
Provide a succinct answer. 1.28. What is the ratio of the Imports (BoP, current US$) of Indonesia in 2005 to that in 2010?
Your response must be concise. 0.59. What is the ratio of the Imports (BoP, current US$) of Malawi in 2005 to that in 2010?
Keep it short and to the point. 0.53. What is the ratio of the Imports (BoP, current US$) of Ecuador in 2006 to that in 2007?
Your answer should be very brief. 0.88. What is the ratio of the Imports (BoP, current US$) of Iceland in 2006 to that in 2007?
Keep it short and to the point. 0.93. What is the ratio of the Imports (BoP, current US$) of Indonesia in 2006 to that in 2007?
Your answer should be compact. 0.86. What is the ratio of the Imports (BoP, current US$) in Malawi in 2006 to that in 2007?
Ensure brevity in your answer.  0.86. What is the ratio of the Imports (BoP, current US$) of Ecuador in 2006 to that in 2008?
Make the answer very short. 0.66. What is the ratio of the Imports (BoP, current US$) in Iceland in 2006 to that in 2008?
Offer a terse response. 1.02. What is the ratio of the Imports (BoP, current US$) of Indonesia in 2006 to that in 2008?
Your answer should be very brief. 0.64. What is the ratio of the Imports (BoP, current US$) of Malawi in 2006 to that in 2008?
Provide a short and direct response. 0.67. What is the ratio of the Imports (BoP, current US$) in Ecuador in 2006 to that in 2009?
Keep it short and to the point. 0.81. What is the ratio of the Imports (BoP, current US$) of Iceland in 2006 to that in 2009?
Your answer should be very brief. 1.77. What is the ratio of the Imports (BoP, current US$) of Indonesia in 2006 to that in 2009?
Provide a succinct answer. 0.84. What is the ratio of the Imports (BoP, current US$) of Malawi in 2006 to that in 2009?
Give a very brief answer. 0.61. What is the ratio of the Imports (BoP, current US$) in Ecuador in 2006 to that in 2010?
Offer a terse response. 0.61. What is the ratio of the Imports (BoP, current US$) of Iceland in 2006 to that in 2010?
Your response must be concise. 1.59. What is the ratio of the Imports (BoP, current US$) of Indonesia in 2006 to that in 2010?
Keep it short and to the point. 0.6. What is the ratio of the Imports (BoP, current US$) in Malawi in 2006 to that in 2010?
Keep it short and to the point. 0.54. What is the ratio of the Imports (BoP, current US$) of Ecuador in 2007 to that in 2008?
Your answer should be very brief. 0.75. What is the ratio of the Imports (BoP, current US$) of Iceland in 2007 to that in 2008?
Your answer should be compact. 1.1. What is the ratio of the Imports (BoP, current US$) in Indonesia in 2007 to that in 2008?
Give a very brief answer. 0.74. What is the ratio of the Imports (BoP, current US$) of Malawi in 2007 to that in 2008?
Offer a very short reply. 0.78. What is the ratio of the Imports (BoP, current US$) of Ecuador in 2007 to that in 2009?
Your answer should be compact. 0.92. What is the ratio of the Imports (BoP, current US$) in Iceland in 2007 to that in 2009?
Provide a succinct answer. 1.91. What is the ratio of the Imports (BoP, current US$) in Indonesia in 2007 to that in 2009?
Your answer should be compact. 0.97. What is the ratio of the Imports (BoP, current US$) in Malawi in 2007 to that in 2009?
Ensure brevity in your answer.  0.71. What is the ratio of the Imports (BoP, current US$) of Ecuador in 2007 to that in 2010?
Your answer should be compact. 0.69. What is the ratio of the Imports (BoP, current US$) of Iceland in 2007 to that in 2010?
Make the answer very short. 1.72. What is the ratio of the Imports (BoP, current US$) of Indonesia in 2007 to that in 2010?
Your answer should be compact. 0.7. What is the ratio of the Imports (BoP, current US$) in Malawi in 2007 to that in 2010?
Your answer should be compact. 0.63. What is the ratio of the Imports (BoP, current US$) in Ecuador in 2008 to that in 2009?
Keep it short and to the point. 1.24. What is the ratio of the Imports (BoP, current US$) of Iceland in 2008 to that in 2009?
Your answer should be very brief. 1.74. What is the ratio of the Imports (BoP, current US$) in Indonesia in 2008 to that in 2009?
Offer a very short reply. 1.31. What is the ratio of the Imports (BoP, current US$) of Malawi in 2008 to that in 2009?
Offer a terse response. 0.91. What is the ratio of the Imports (BoP, current US$) of Ecuador in 2008 to that in 2010?
Your response must be concise. 0.92. What is the ratio of the Imports (BoP, current US$) in Iceland in 2008 to that in 2010?
Provide a short and direct response. 1.56. What is the ratio of the Imports (BoP, current US$) of Indonesia in 2008 to that in 2010?
Your answer should be very brief. 0.94. What is the ratio of the Imports (BoP, current US$) in Malawi in 2008 to that in 2010?
Give a very brief answer. 0.8. What is the ratio of the Imports (BoP, current US$) of Ecuador in 2009 to that in 2010?
Your answer should be very brief. 0.75. What is the ratio of the Imports (BoP, current US$) in Iceland in 2009 to that in 2010?
Your answer should be very brief. 0.9. What is the ratio of the Imports (BoP, current US$) in Indonesia in 2009 to that in 2010?
Ensure brevity in your answer.  0.72. What is the ratio of the Imports (BoP, current US$) in Malawi in 2009 to that in 2010?
Offer a very short reply. 0.89. What is the difference between the highest and the second highest Imports (BoP, current US$) of Ecuador?
Offer a terse response. 1.71e+09. What is the difference between the highest and the second highest Imports (BoP, current US$) in Iceland?
Make the answer very short. 4.53e+08. What is the difference between the highest and the second highest Imports (BoP, current US$) of Indonesia?
Your response must be concise. 9.29e+09. What is the difference between the highest and the second highest Imports (BoP, current US$) in Malawi?
Offer a very short reply. 2.83e+08. What is the difference between the highest and the lowest Imports (BoP, current US$) of Ecuador?
Provide a short and direct response. 1.08e+1. What is the difference between the highest and the lowest Imports (BoP, current US$) in Iceland?
Provide a succinct answer. 2.99e+09. What is the difference between the highest and the lowest Imports (BoP, current US$) of Indonesia?
Ensure brevity in your answer.  5.92e+1. What is the difference between the highest and the lowest Imports (BoP, current US$) of Malawi?
Offer a very short reply. 1.15e+09. 